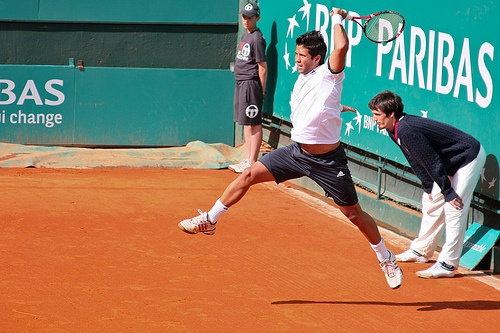Describe the objects in this image and their specific colors. I can see people in teal, white, black, maroon, and darkgray tones, people in teal, black, white, and darkgray tones, people in teal, gray, black, and lightpink tones, and tennis racket in teal, lightgray, and darkgray tones in this image. 